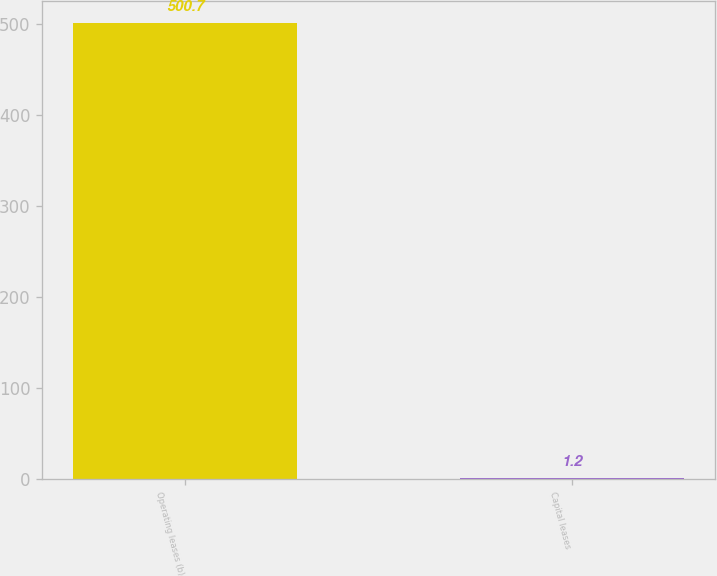<chart> <loc_0><loc_0><loc_500><loc_500><bar_chart><fcel>Operating leases (b)<fcel>Capital leases<nl><fcel>500.7<fcel>1.2<nl></chart> 